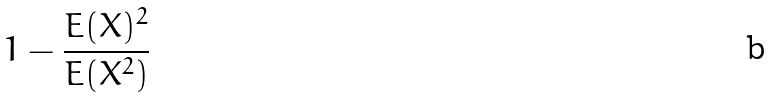<formula> <loc_0><loc_0><loc_500><loc_500>1 - \frac { E ( X ) ^ { 2 } } { E ( X ^ { 2 } ) }</formula> 